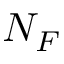<formula> <loc_0><loc_0><loc_500><loc_500>N _ { F }</formula> 